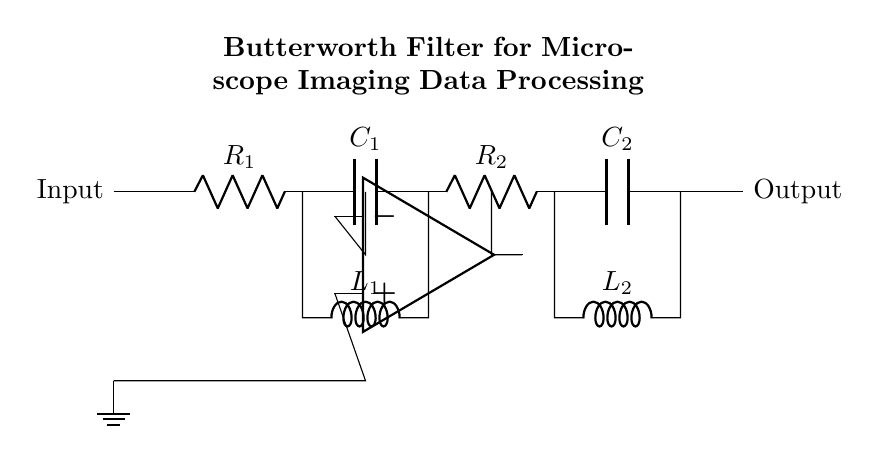What is the type of filter represented by this circuit? The circuit is a Butterworth filter, which is indicated in the title of the circuit diagram. Butterworth filters are known for their maximally flat frequency response in the passband.
Answer: Butterworth filter How many resistors are present in the circuit? There are two resistors labeled R1 and R2 in the circuit diagram. Each component type can be counted individually.
Answer: 2 What components are used in the first stage of the filter? The first stage consists of a resistor (R1), a capacitor (C1), and an inductor (L1). These components are connected in series.
Answer: R1, C1, L1 Where is the operational amplifier located in the circuit? The operational amplifier is positioned in the middle section of the circuit, below the first stage and above the output line. Its symbol can be identified among the other components.
Answer: Middle section What is the function of the capacitors in this Butterworth filter? Capacitors are used to block DC voltage while allowing AC signals to pass, thereby aiding in frequency selection in the filter design. In a Butterworth filter, they help in shaping the frequency response.
Answer: Frequency selection What connections are made to the input and output of this circuit? The input enters the circuit at the left side and is connected to the first stage, while the output is taken from the end of the second stage at the right side. This connection allows for processing the signal through the filter stages.
Answer: Left to right connection What role does the inductor play in the circuit? Inductors are used to store energy in a magnetic field and oppose changes in current, which helps in filtering specific frequency ranges as they work with capacitors in tuned circuits to create frequency-selective networks.
Answer: Store energy 